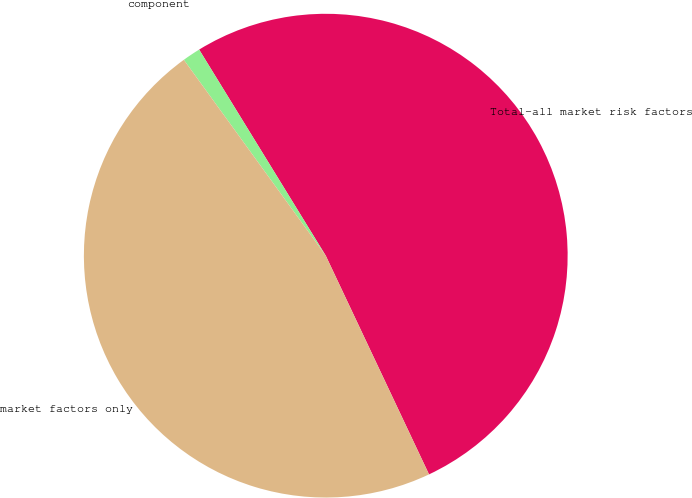<chart> <loc_0><loc_0><loc_500><loc_500><pie_chart><fcel>Total-all market risk factors<fcel>component<fcel>market factors only<nl><fcel>51.75%<fcel>1.21%<fcel>47.04%<nl></chart> 